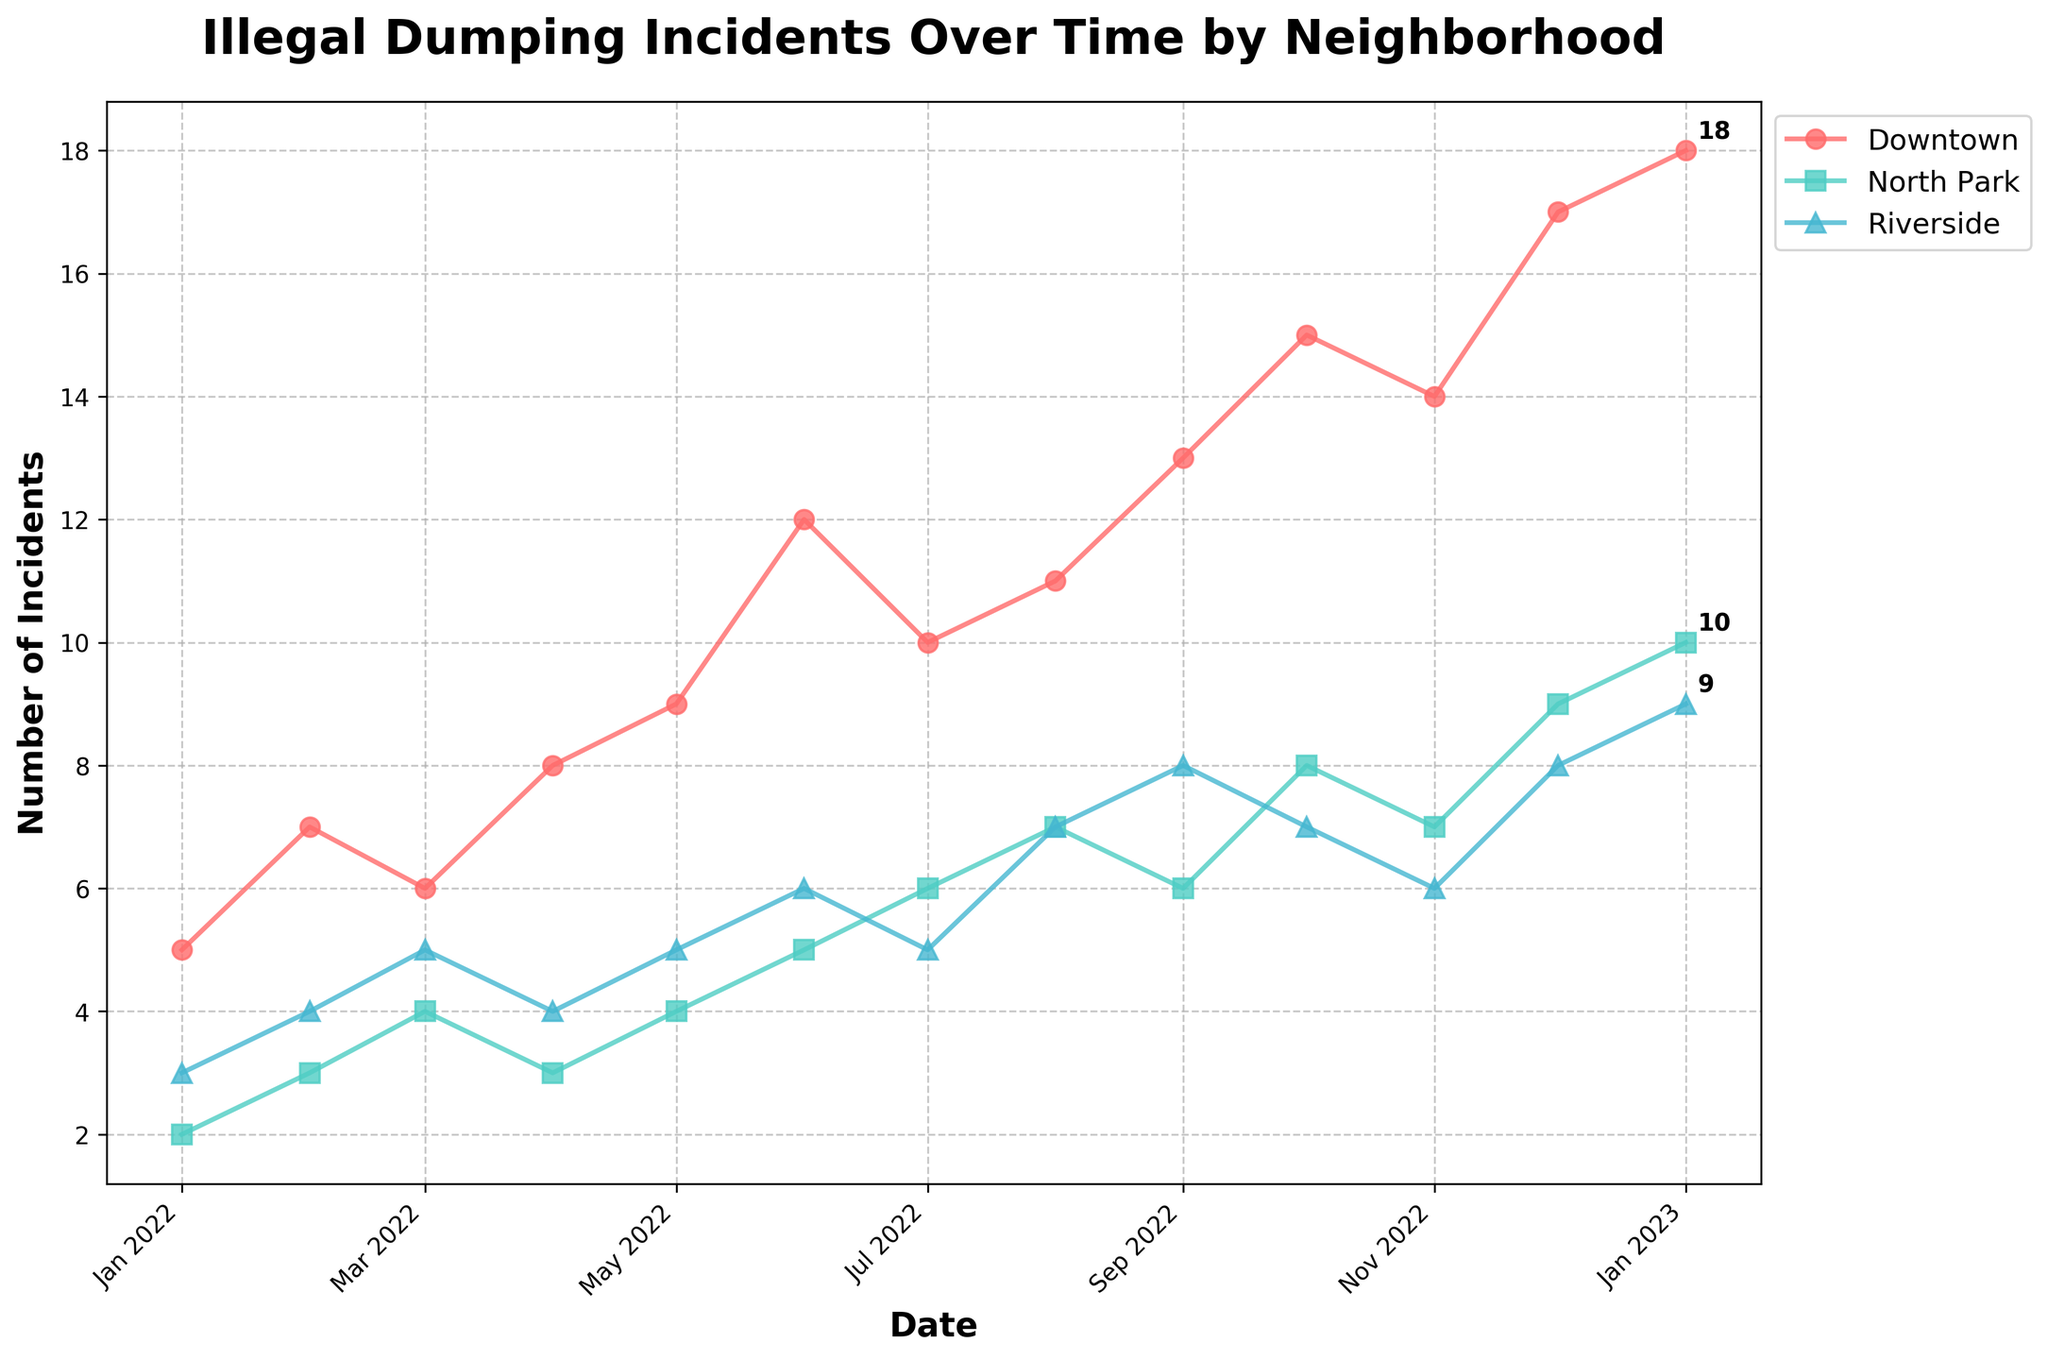what is the title of the figure? The title can be found at the top of the figure in a larger font. It typically explains what the figure is about.
Answer: Illegal Dumping Incidents Over Time by Neighborhood What is the highest number of incidents in Downtown, and in which month did it occur? To find this, locate the highest data point on the Downtown line and note the corresponding month.
Answer: 18 in January 2023 Which neighborhood had the least number of illegal dumping incidents in January 2022 and how many incidents were there? To answer, compare the data points for January 2022 for all neighborhoods and identify the smallest one.
Answer: North Park with 2 incidents How did the number of incidents in Riverside change from January 2022 to January 2023? To determine this, subtract the Riverside incident count in January 2022 from January 2023.
Answer: Increased by 6 (from 3 to 9) Which neighborhood shows the most consistent trend in the number of incidents? Look for the line that is the most steady and has the least amount of fluctuation over time.
Answer: Riverside By how much did the number of dumping incidents in North Park increase from December 2022 to January 2023? Find the values for North Park in both months and subtract the December value from the January value.
Answer: Increased by 1 (from 9 to 10) What can be inferred about the seasonal trend of dumping incidents in Downtown based on the plotted data? Examine the patterns and trends throughout the months and seasons to draw an inference.
Answer: Incidents tend to increase towards the end of the year On average, how many illegal dumping incidents occurred in Riverside each month in 2022? Sum all the monthly incidents for Riverside in 2022, then divide by the number of months.
Answer: (3 + 4 + 5 + 4 + 5 + 6 + 5 + 7 + 8 + 7 + 6 + 8) / 12 = 5.5 Comparing October incidents, which neighborhood had the highest rise in incidents compared to September? Find the difference in incidents for each neighborhood between September and October, and identify the highest increase.
Answer: Downtown increased by 2 incidents (from 13 to 15) When did North Park see a noticeable uptick in illegal dumping incidents during the reported period? Identify any month where North Park has a sharp increase in the number of incidents compared to previous months.
Answer: August 2022 (increased from 6 to 7 incidents) Which neighborhood had the highest increase in illegal dumping incidents from November 2022 to December 2022? Compare the incident numbers from November to December for each neighborhood and find the largest increase.
Answer: All neighborhoods increased, but Downtown had the highest increase by 3 incidents (from 14 to 17) 